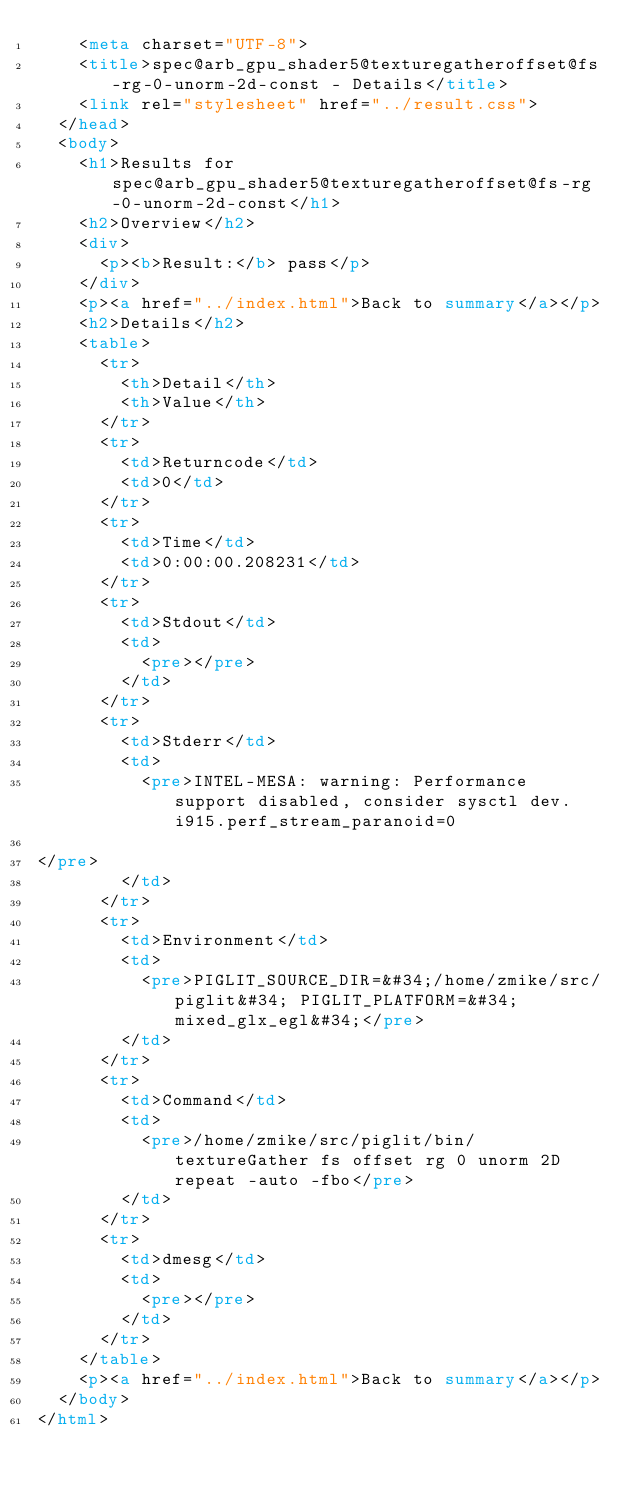<code> <loc_0><loc_0><loc_500><loc_500><_HTML_>    <meta charset="UTF-8">
    <title>spec@arb_gpu_shader5@texturegatheroffset@fs-rg-0-unorm-2d-const - Details</title>
    <link rel="stylesheet" href="../result.css">
  </head>
  <body>
    <h1>Results for spec@arb_gpu_shader5@texturegatheroffset@fs-rg-0-unorm-2d-const</h1>
    <h2>Overview</h2>
    <div>
      <p><b>Result:</b> pass</p>
    </div>
    <p><a href="../index.html">Back to summary</a></p>
    <h2>Details</h2>
    <table>
      <tr>
        <th>Detail</th>
        <th>Value</th>
      </tr>
      <tr>
        <td>Returncode</td>
        <td>0</td>
      </tr>
      <tr>
        <td>Time</td>
        <td>0:00:00.208231</td>
      </tr>
      <tr>
        <td>Stdout</td>
        <td>
          <pre></pre>
        </td>
      </tr>
      <tr>
        <td>Stderr</td>
        <td>
          <pre>INTEL-MESA: warning: Performance support disabled, consider sysctl dev.i915.perf_stream_paranoid=0

</pre>
        </td>
      </tr>
      <tr>
        <td>Environment</td>
        <td>
          <pre>PIGLIT_SOURCE_DIR=&#34;/home/zmike/src/piglit&#34; PIGLIT_PLATFORM=&#34;mixed_glx_egl&#34;</pre>
        </td>
      </tr>
      <tr>
        <td>Command</td>
        <td>
          <pre>/home/zmike/src/piglit/bin/textureGather fs offset rg 0 unorm 2D repeat -auto -fbo</pre>
        </td>
      </tr>
      <tr>
        <td>dmesg</td>
        <td>
          <pre></pre>
        </td>
      </tr>
    </table>
    <p><a href="../index.html">Back to summary</a></p>
  </body>
</html>
</code> 